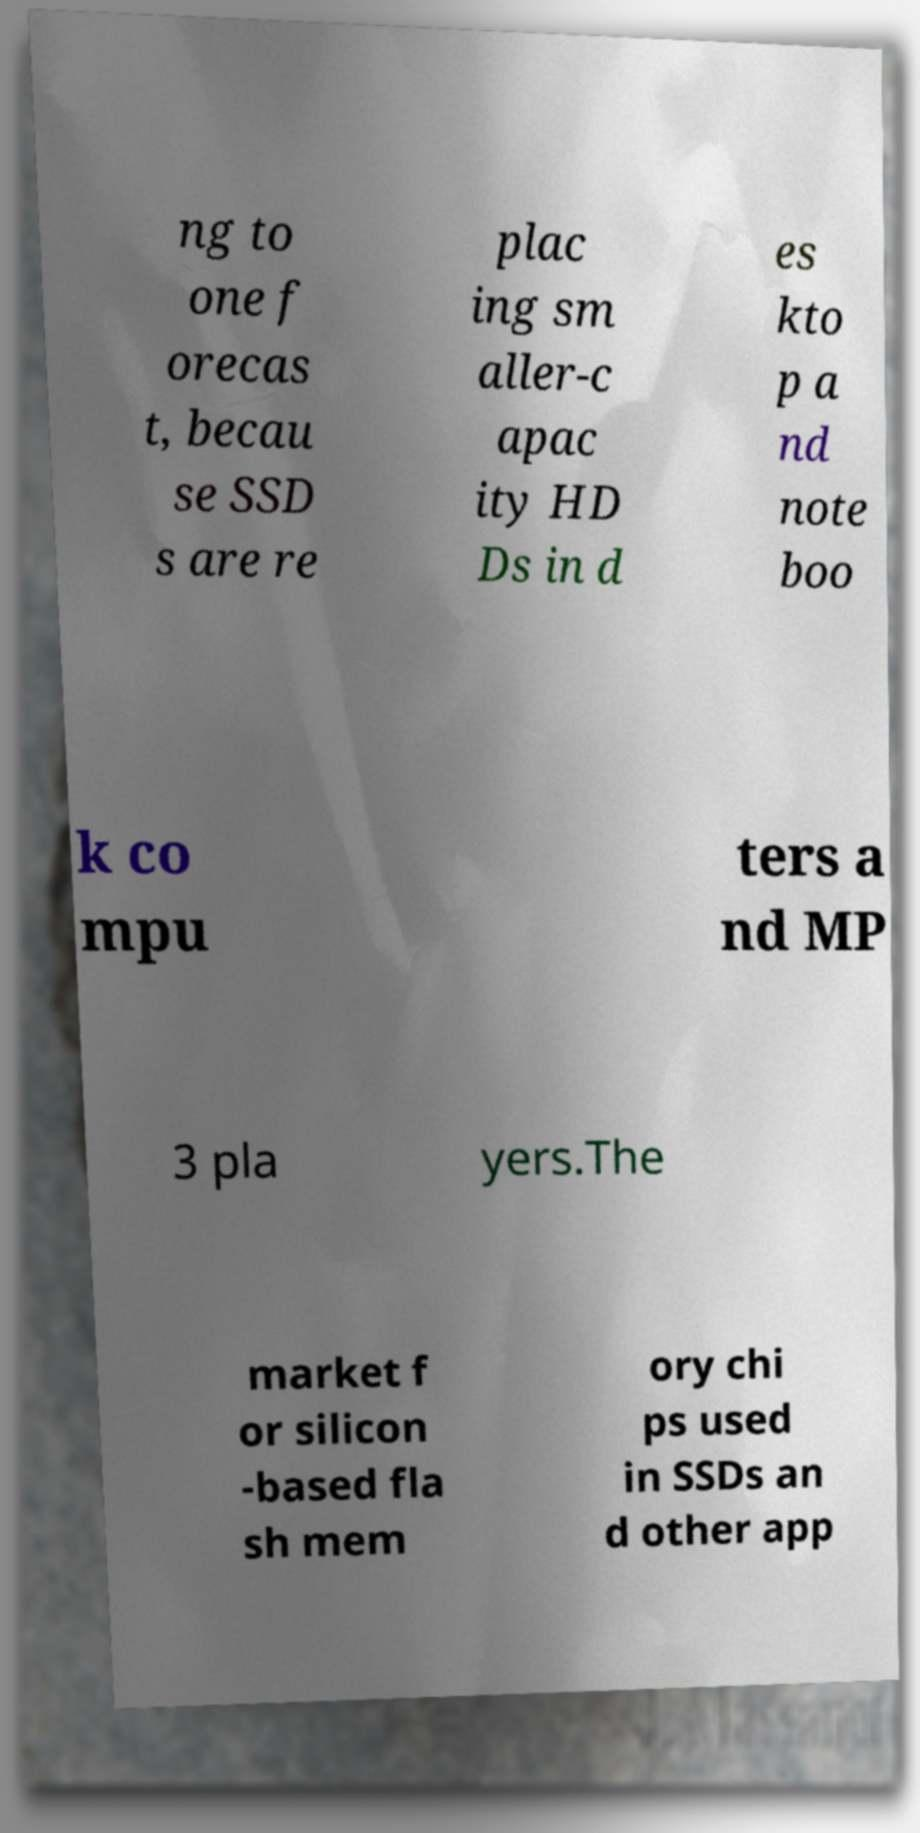Could you assist in decoding the text presented in this image and type it out clearly? ng to one f orecas t, becau se SSD s are re plac ing sm aller-c apac ity HD Ds in d es kto p a nd note boo k co mpu ters a nd MP 3 pla yers.The market f or silicon -based fla sh mem ory chi ps used in SSDs an d other app 